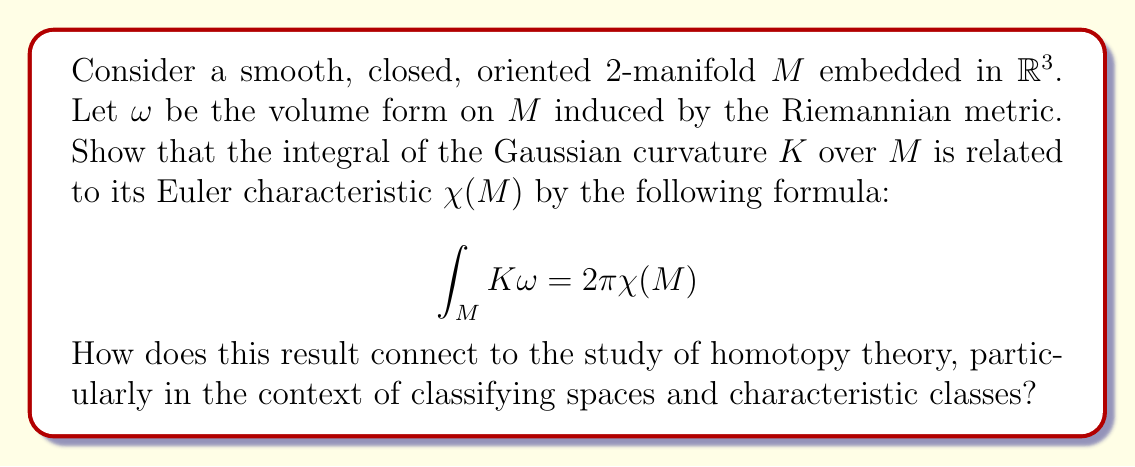Teach me how to tackle this problem. To approach this problem, we'll follow these steps:

1) First, we recall the Gauss-Bonnet theorem, which states that for a closed, oriented 2-manifold $M$:

   $$\int_M K dA = 2\pi \chi(M)$$

   where $dA$ is the area element of $M$.

2) In our case, $\omega$ is the volume form on $M$, which is equivalent to the area element $dA$. This explains why the left-hand side of our equation matches the Gauss-Bonnet theorem.

3) The Euler characteristic $\chi(M)$ is a topological invariant of $M$. It's defined as:

   $$\chi(M) = V - E + F$$

   where $V$, $E$, and $F$ are the numbers of vertices, edges, and faces in any triangulation of $M$.

4) The connection to homotopy theory comes through the concept of classifying spaces and characteristic classes:

   a) The Euler characteristic can be interpreted as the evaluation of the Euler class $e(TM)$ on the fundamental class $[M]$:

      $$\chi(M) = \langle e(TM), [M] \rangle$$

   b) The Euler class $e(TM)$ is a characteristic class of the tangent bundle $TM$. Characteristic classes are cohomology classes associated to vector bundles, which play a crucial role in algebraic topology and homotopy theory.

   c) The classifying space $BO(2)$ for oriented 2-plane bundles has a universal Euler class $e \in H^2(BO(2); \mathbb{Z})$. The Euler class of $TM$ is the pullback of this universal class via the classifying map $f: M \to BO(2)$ of the tangent bundle:

      $$e(TM) = f^*(e)$$

5) In homotopy theory, we study the homotopy groups of spaces and the maps between them. The classifying map $f: M \to BO(2)$ represents an element in the set $[M, BO(2)]$ of homotopy classes of maps from $M$ to $BO(2)$. This set classifies oriented 2-plane bundles over $M$ up to isomorphism.

6) The integral formula $\int_M K \omega = 2\pi \chi(M)$ thus connects local differential geometric information (curvature) with global topological information (Euler characteristic). This bridge between geometry and topology is a recurring theme in homotopy theory, particularly in the study of characteristic classes and their applications.

7) Furthermore, this result generalizes to higher dimensions through the Chern-Gauss-Bonnet theorem, which relates the Euler characteristic of a compact, oriented, even-dimensional Riemannian manifold to the integral of its Pfaffian. This generalization involves more sophisticated tools from differential geometry and algebraic topology, including the theory of Chern classes, which are fundamental in the study of complex vector bundles and their classifying spaces.
Answer: The integral formula $\int_M K \omega = 2\pi \chi(M)$ connects to homotopy theory through the concept of classifying spaces and characteristic classes. The Euler characteristic $\chi(M)$ can be interpreted as the evaluation of the Euler class $e(TM)$ on the fundamental class $[M]$. The Euler class, being a characteristic class, is defined via the classifying map $f: M \to BO(2)$, which represents an element in the set $[M, BO(2)]$ of homotopy classes. This connection provides a bridge between local differential geometry (curvature) and global algebraic topology (characteristic classes), which is a central theme in homotopy theory and its applications to the study of manifolds. 